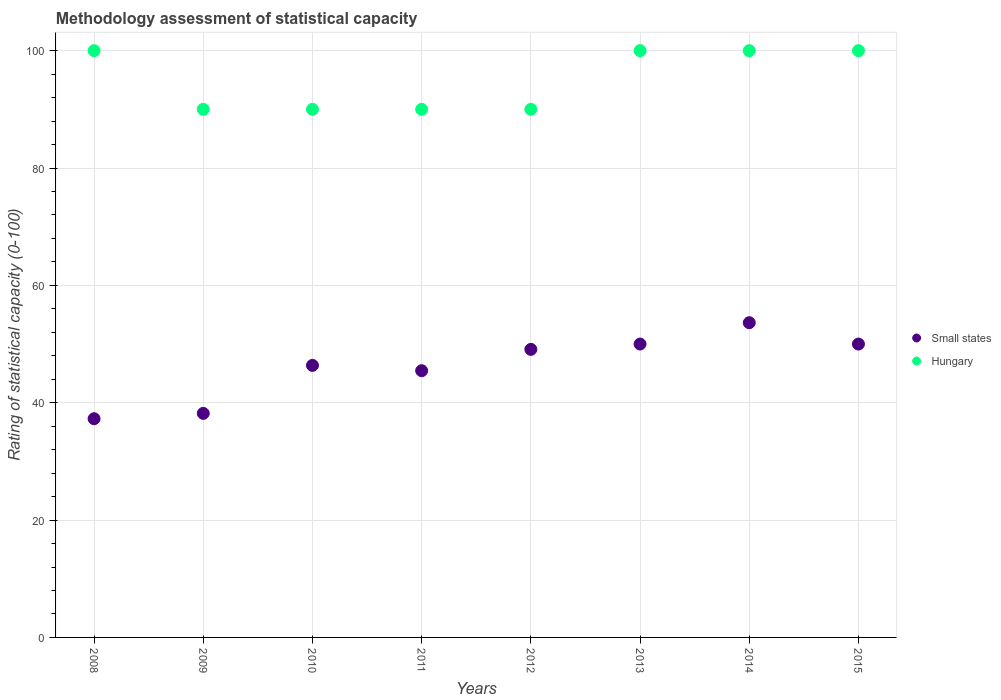Is the number of dotlines equal to the number of legend labels?
Your response must be concise. Yes. What is the rating of statistical capacity in Hungary in 2008?
Make the answer very short. 100. Across all years, what is the maximum rating of statistical capacity in Small states?
Make the answer very short. 53.64. Across all years, what is the minimum rating of statistical capacity in Hungary?
Your response must be concise. 90. In which year was the rating of statistical capacity in Small states maximum?
Your response must be concise. 2014. In which year was the rating of statistical capacity in Small states minimum?
Provide a succinct answer. 2008. What is the total rating of statistical capacity in Hungary in the graph?
Your answer should be compact. 760. What is the difference between the rating of statistical capacity in Small states in 2010 and that in 2011?
Keep it short and to the point. 0.91. What is the difference between the rating of statistical capacity in Small states in 2010 and the rating of statistical capacity in Hungary in 2012?
Give a very brief answer. -43.64. What is the average rating of statistical capacity in Small states per year?
Provide a short and direct response. 46.25. In the year 2008, what is the difference between the rating of statistical capacity in Hungary and rating of statistical capacity in Small states?
Provide a succinct answer. 62.73. Is the difference between the rating of statistical capacity in Hungary in 2008 and 2009 greater than the difference between the rating of statistical capacity in Small states in 2008 and 2009?
Keep it short and to the point. Yes. What is the difference between the highest and the second highest rating of statistical capacity in Hungary?
Keep it short and to the point. 0. What is the difference between the highest and the lowest rating of statistical capacity in Small states?
Provide a short and direct response. 16.36. In how many years, is the rating of statistical capacity in Hungary greater than the average rating of statistical capacity in Hungary taken over all years?
Your answer should be compact. 4. Is the sum of the rating of statistical capacity in Small states in 2008 and 2014 greater than the maximum rating of statistical capacity in Hungary across all years?
Give a very brief answer. No. Does the rating of statistical capacity in Hungary monotonically increase over the years?
Offer a terse response. No. Is the rating of statistical capacity in Hungary strictly less than the rating of statistical capacity in Small states over the years?
Provide a succinct answer. No. How many dotlines are there?
Ensure brevity in your answer.  2. How many years are there in the graph?
Offer a very short reply. 8. What is the difference between two consecutive major ticks on the Y-axis?
Offer a terse response. 20. Are the values on the major ticks of Y-axis written in scientific E-notation?
Your answer should be very brief. No. Does the graph contain grids?
Offer a terse response. Yes. Where does the legend appear in the graph?
Your answer should be compact. Center right. How many legend labels are there?
Ensure brevity in your answer.  2. How are the legend labels stacked?
Offer a terse response. Vertical. What is the title of the graph?
Your answer should be very brief. Methodology assessment of statistical capacity. Does "Bahrain" appear as one of the legend labels in the graph?
Provide a short and direct response. No. What is the label or title of the Y-axis?
Your answer should be very brief. Rating of statistical capacity (0-100). What is the Rating of statistical capacity (0-100) of Small states in 2008?
Your answer should be compact. 37.27. What is the Rating of statistical capacity (0-100) of Small states in 2009?
Ensure brevity in your answer.  38.18. What is the Rating of statistical capacity (0-100) of Hungary in 2009?
Your answer should be compact. 90. What is the Rating of statistical capacity (0-100) of Small states in 2010?
Your answer should be compact. 46.36. What is the Rating of statistical capacity (0-100) of Hungary in 2010?
Make the answer very short. 90. What is the Rating of statistical capacity (0-100) of Small states in 2011?
Offer a terse response. 45.45. What is the Rating of statistical capacity (0-100) of Hungary in 2011?
Your response must be concise. 90. What is the Rating of statistical capacity (0-100) in Small states in 2012?
Ensure brevity in your answer.  49.09. What is the Rating of statistical capacity (0-100) of Hungary in 2013?
Ensure brevity in your answer.  100. What is the Rating of statistical capacity (0-100) of Small states in 2014?
Keep it short and to the point. 53.64. What is the Rating of statistical capacity (0-100) in Hungary in 2015?
Your response must be concise. 100. Across all years, what is the maximum Rating of statistical capacity (0-100) of Small states?
Provide a succinct answer. 53.64. Across all years, what is the minimum Rating of statistical capacity (0-100) in Small states?
Your response must be concise. 37.27. Across all years, what is the minimum Rating of statistical capacity (0-100) of Hungary?
Your response must be concise. 90. What is the total Rating of statistical capacity (0-100) in Small states in the graph?
Your response must be concise. 370. What is the total Rating of statistical capacity (0-100) in Hungary in the graph?
Provide a short and direct response. 760. What is the difference between the Rating of statistical capacity (0-100) in Small states in 2008 and that in 2009?
Ensure brevity in your answer.  -0.91. What is the difference between the Rating of statistical capacity (0-100) in Hungary in 2008 and that in 2009?
Provide a succinct answer. 10. What is the difference between the Rating of statistical capacity (0-100) of Small states in 2008 and that in 2010?
Your answer should be compact. -9.09. What is the difference between the Rating of statistical capacity (0-100) of Hungary in 2008 and that in 2010?
Provide a succinct answer. 10. What is the difference between the Rating of statistical capacity (0-100) of Small states in 2008 and that in 2011?
Your answer should be very brief. -8.18. What is the difference between the Rating of statistical capacity (0-100) in Small states in 2008 and that in 2012?
Keep it short and to the point. -11.82. What is the difference between the Rating of statistical capacity (0-100) of Small states in 2008 and that in 2013?
Provide a succinct answer. -12.73. What is the difference between the Rating of statistical capacity (0-100) of Small states in 2008 and that in 2014?
Your answer should be very brief. -16.36. What is the difference between the Rating of statistical capacity (0-100) of Hungary in 2008 and that in 2014?
Your answer should be very brief. 0. What is the difference between the Rating of statistical capacity (0-100) of Small states in 2008 and that in 2015?
Give a very brief answer. -12.73. What is the difference between the Rating of statistical capacity (0-100) of Hungary in 2008 and that in 2015?
Ensure brevity in your answer.  0. What is the difference between the Rating of statistical capacity (0-100) of Small states in 2009 and that in 2010?
Give a very brief answer. -8.18. What is the difference between the Rating of statistical capacity (0-100) of Small states in 2009 and that in 2011?
Keep it short and to the point. -7.27. What is the difference between the Rating of statistical capacity (0-100) in Hungary in 2009 and that in 2011?
Offer a terse response. 0. What is the difference between the Rating of statistical capacity (0-100) in Small states in 2009 and that in 2012?
Provide a short and direct response. -10.91. What is the difference between the Rating of statistical capacity (0-100) of Hungary in 2009 and that in 2012?
Keep it short and to the point. 0. What is the difference between the Rating of statistical capacity (0-100) in Small states in 2009 and that in 2013?
Keep it short and to the point. -11.82. What is the difference between the Rating of statistical capacity (0-100) in Small states in 2009 and that in 2014?
Ensure brevity in your answer.  -15.45. What is the difference between the Rating of statistical capacity (0-100) of Small states in 2009 and that in 2015?
Make the answer very short. -11.82. What is the difference between the Rating of statistical capacity (0-100) of Hungary in 2009 and that in 2015?
Keep it short and to the point. -10. What is the difference between the Rating of statistical capacity (0-100) in Small states in 2010 and that in 2012?
Give a very brief answer. -2.73. What is the difference between the Rating of statistical capacity (0-100) in Small states in 2010 and that in 2013?
Make the answer very short. -3.64. What is the difference between the Rating of statistical capacity (0-100) in Small states in 2010 and that in 2014?
Offer a terse response. -7.27. What is the difference between the Rating of statistical capacity (0-100) of Small states in 2010 and that in 2015?
Keep it short and to the point. -3.64. What is the difference between the Rating of statistical capacity (0-100) in Small states in 2011 and that in 2012?
Give a very brief answer. -3.64. What is the difference between the Rating of statistical capacity (0-100) in Hungary in 2011 and that in 2012?
Your answer should be very brief. 0. What is the difference between the Rating of statistical capacity (0-100) of Small states in 2011 and that in 2013?
Your response must be concise. -4.55. What is the difference between the Rating of statistical capacity (0-100) of Hungary in 2011 and that in 2013?
Provide a succinct answer. -10. What is the difference between the Rating of statistical capacity (0-100) of Small states in 2011 and that in 2014?
Ensure brevity in your answer.  -8.18. What is the difference between the Rating of statistical capacity (0-100) of Hungary in 2011 and that in 2014?
Keep it short and to the point. -10. What is the difference between the Rating of statistical capacity (0-100) in Small states in 2011 and that in 2015?
Offer a terse response. -4.55. What is the difference between the Rating of statistical capacity (0-100) of Small states in 2012 and that in 2013?
Your answer should be very brief. -0.91. What is the difference between the Rating of statistical capacity (0-100) in Small states in 2012 and that in 2014?
Your response must be concise. -4.55. What is the difference between the Rating of statistical capacity (0-100) of Small states in 2012 and that in 2015?
Make the answer very short. -0.91. What is the difference between the Rating of statistical capacity (0-100) in Hungary in 2012 and that in 2015?
Provide a succinct answer. -10. What is the difference between the Rating of statistical capacity (0-100) in Small states in 2013 and that in 2014?
Your answer should be very brief. -3.64. What is the difference between the Rating of statistical capacity (0-100) in Hungary in 2013 and that in 2014?
Ensure brevity in your answer.  0. What is the difference between the Rating of statistical capacity (0-100) of Small states in 2014 and that in 2015?
Your answer should be compact. 3.64. What is the difference between the Rating of statistical capacity (0-100) of Hungary in 2014 and that in 2015?
Provide a short and direct response. 0. What is the difference between the Rating of statistical capacity (0-100) in Small states in 2008 and the Rating of statistical capacity (0-100) in Hungary in 2009?
Your response must be concise. -52.73. What is the difference between the Rating of statistical capacity (0-100) in Small states in 2008 and the Rating of statistical capacity (0-100) in Hungary in 2010?
Make the answer very short. -52.73. What is the difference between the Rating of statistical capacity (0-100) of Small states in 2008 and the Rating of statistical capacity (0-100) of Hungary in 2011?
Your answer should be very brief. -52.73. What is the difference between the Rating of statistical capacity (0-100) of Small states in 2008 and the Rating of statistical capacity (0-100) of Hungary in 2012?
Provide a succinct answer. -52.73. What is the difference between the Rating of statistical capacity (0-100) of Small states in 2008 and the Rating of statistical capacity (0-100) of Hungary in 2013?
Give a very brief answer. -62.73. What is the difference between the Rating of statistical capacity (0-100) in Small states in 2008 and the Rating of statistical capacity (0-100) in Hungary in 2014?
Give a very brief answer. -62.73. What is the difference between the Rating of statistical capacity (0-100) in Small states in 2008 and the Rating of statistical capacity (0-100) in Hungary in 2015?
Provide a succinct answer. -62.73. What is the difference between the Rating of statistical capacity (0-100) of Small states in 2009 and the Rating of statistical capacity (0-100) of Hungary in 2010?
Make the answer very short. -51.82. What is the difference between the Rating of statistical capacity (0-100) of Small states in 2009 and the Rating of statistical capacity (0-100) of Hungary in 2011?
Make the answer very short. -51.82. What is the difference between the Rating of statistical capacity (0-100) of Small states in 2009 and the Rating of statistical capacity (0-100) of Hungary in 2012?
Your answer should be very brief. -51.82. What is the difference between the Rating of statistical capacity (0-100) in Small states in 2009 and the Rating of statistical capacity (0-100) in Hungary in 2013?
Keep it short and to the point. -61.82. What is the difference between the Rating of statistical capacity (0-100) in Small states in 2009 and the Rating of statistical capacity (0-100) in Hungary in 2014?
Make the answer very short. -61.82. What is the difference between the Rating of statistical capacity (0-100) in Small states in 2009 and the Rating of statistical capacity (0-100) in Hungary in 2015?
Provide a succinct answer. -61.82. What is the difference between the Rating of statistical capacity (0-100) of Small states in 2010 and the Rating of statistical capacity (0-100) of Hungary in 2011?
Ensure brevity in your answer.  -43.64. What is the difference between the Rating of statistical capacity (0-100) of Small states in 2010 and the Rating of statistical capacity (0-100) of Hungary in 2012?
Give a very brief answer. -43.64. What is the difference between the Rating of statistical capacity (0-100) of Small states in 2010 and the Rating of statistical capacity (0-100) of Hungary in 2013?
Provide a short and direct response. -53.64. What is the difference between the Rating of statistical capacity (0-100) of Small states in 2010 and the Rating of statistical capacity (0-100) of Hungary in 2014?
Provide a succinct answer. -53.64. What is the difference between the Rating of statistical capacity (0-100) of Small states in 2010 and the Rating of statistical capacity (0-100) of Hungary in 2015?
Your answer should be very brief. -53.64. What is the difference between the Rating of statistical capacity (0-100) of Small states in 2011 and the Rating of statistical capacity (0-100) of Hungary in 2012?
Your answer should be compact. -44.55. What is the difference between the Rating of statistical capacity (0-100) of Small states in 2011 and the Rating of statistical capacity (0-100) of Hungary in 2013?
Give a very brief answer. -54.55. What is the difference between the Rating of statistical capacity (0-100) of Small states in 2011 and the Rating of statistical capacity (0-100) of Hungary in 2014?
Offer a terse response. -54.55. What is the difference between the Rating of statistical capacity (0-100) of Small states in 2011 and the Rating of statistical capacity (0-100) of Hungary in 2015?
Provide a short and direct response. -54.55. What is the difference between the Rating of statistical capacity (0-100) in Small states in 2012 and the Rating of statistical capacity (0-100) in Hungary in 2013?
Give a very brief answer. -50.91. What is the difference between the Rating of statistical capacity (0-100) in Small states in 2012 and the Rating of statistical capacity (0-100) in Hungary in 2014?
Make the answer very short. -50.91. What is the difference between the Rating of statistical capacity (0-100) in Small states in 2012 and the Rating of statistical capacity (0-100) in Hungary in 2015?
Your answer should be very brief. -50.91. What is the difference between the Rating of statistical capacity (0-100) in Small states in 2013 and the Rating of statistical capacity (0-100) in Hungary in 2014?
Your answer should be compact. -50. What is the difference between the Rating of statistical capacity (0-100) in Small states in 2014 and the Rating of statistical capacity (0-100) in Hungary in 2015?
Keep it short and to the point. -46.36. What is the average Rating of statistical capacity (0-100) of Small states per year?
Your answer should be compact. 46.25. What is the average Rating of statistical capacity (0-100) in Hungary per year?
Offer a very short reply. 95. In the year 2008, what is the difference between the Rating of statistical capacity (0-100) in Small states and Rating of statistical capacity (0-100) in Hungary?
Your response must be concise. -62.73. In the year 2009, what is the difference between the Rating of statistical capacity (0-100) in Small states and Rating of statistical capacity (0-100) in Hungary?
Your response must be concise. -51.82. In the year 2010, what is the difference between the Rating of statistical capacity (0-100) of Small states and Rating of statistical capacity (0-100) of Hungary?
Provide a short and direct response. -43.64. In the year 2011, what is the difference between the Rating of statistical capacity (0-100) of Small states and Rating of statistical capacity (0-100) of Hungary?
Provide a short and direct response. -44.55. In the year 2012, what is the difference between the Rating of statistical capacity (0-100) in Small states and Rating of statistical capacity (0-100) in Hungary?
Offer a terse response. -40.91. In the year 2013, what is the difference between the Rating of statistical capacity (0-100) of Small states and Rating of statistical capacity (0-100) of Hungary?
Your response must be concise. -50. In the year 2014, what is the difference between the Rating of statistical capacity (0-100) of Small states and Rating of statistical capacity (0-100) of Hungary?
Offer a very short reply. -46.36. In the year 2015, what is the difference between the Rating of statistical capacity (0-100) in Small states and Rating of statistical capacity (0-100) in Hungary?
Your answer should be compact. -50. What is the ratio of the Rating of statistical capacity (0-100) of Small states in 2008 to that in 2009?
Offer a terse response. 0.98. What is the ratio of the Rating of statistical capacity (0-100) of Small states in 2008 to that in 2010?
Offer a very short reply. 0.8. What is the ratio of the Rating of statistical capacity (0-100) in Small states in 2008 to that in 2011?
Provide a succinct answer. 0.82. What is the ratio of the Rating of statistical capacity (0-100) in Small states in 2008 to that in 2012?
Your response must be concise. 0.76. What is the ratio of the Rating of statistical capacity (0-100) in Hungary in 2008 to that in 2012?
Offer a very short reply. 1.11. What is the ratio of the Rating of statistical capacity (0-100) in Small states in 2008 to that in 2013?
Keep it short and to the point. 0.75. What is the ratio of the Rating of statistical capacity (0-100) in Small states in 2008 to that in 2014?
Ensure brevity in your answer.  0.69. What is the ratio of the Rating of statistical capacity (0-100) of Hungary in 2008 to that in 2014?
Your answer should be compact. 1. What is the ratio of the Rating of statistical capacity (0-100) in Small states in 2008 to that in 2015?
Keep it short and to the point. 0.75. What is the ratio of the Rating of statistical capacity (0-100) of Hungary in 2008 to that in 2015?
Ensure brevity in your answer.  1. What is the ratio of the Rating of statistical capacity (0-100) of Small states in 2009 to that in 2010?
Make the answer very short. 0.82. What is the ratio of the Rating of statistical capacity (0-100) of Hungary in 2009 to that in 2010?
Your answer should be very brief. 1. What is the ratio of the Rating of statistical capacity (0-100) of Small states in 2009 to that in 2011?
Give a very brief answer. 0.84. What is the ratio of the Rating of statistical capacity (0-100) in Hungary in 2009 to that in 2011?
Keep it short and to the point. 1. What is the ratio of the Rating of statistical capacity (0-100) of Small states in 2009 to that in 2012?
Provide a short and direct response. 0.78. What is the ratio of the Rating of statistical capacity (0-100) of Small states in 2009 to that in 2013?
Your response must be concise. 0.76. What is the ratio of the Rating of statistical capacity (0-100) of Hungary in 2009 to that in 2013?
Keep it short and to the point. 0.9. What is the ratio of the Rating of statistical capacity (0-100) in Small states in 2009 to that in 2014?
Provide a succinct answer. 0.71. What is the ratio of the Rating of statistical capacity (0-100) in Hungary in 2009 to that in 2014?
Offer a terse response. 0.9. What is the ratio of the Rating of statistical capacity (0-100) in Small states in 2009 to that in 2015?
Provide a short and direct response. 0.76. What is the ratio of the Rating of statistical capacity (0-100) of Hungary in 2009 to that in 2015?
Provide a short and direct response. 0.9. What is the ratio of the Rating of statistical capacity (0-100) in Small states in 2010 to that in 2011?
Your answer should be compact. 1.02. What is the ratio of the Rating of statistical capacity (0-100) of Hungary in 2010 to that in 2011?
Ensure brevity in your answer.  1. What is the ratio of the Rating of statistical capacity (0-100) in Small states in 2010 to that in 2012?
Your answer should be very brief. 0.94. What is the ratio of the Rating of statistical capacity (0-100) of Hungary in 2010 to that in 2012?
Your response must be concise. 1. What is the ratio of the Rating of statistical capacity (0-100) in Small states in 2010 to that in 2013?
Make the answer very short. 0.93. What is the ratio of the Rating of statistical capacity (0-100) in Small states in 2010 to that in 2014?
Offer a terse response. 0.86. What is the ratio of the Rating of statistical capacity (0-100) in Hungary in 2010 to that in 2014?
Your answer should be compact. 0.9. What is the ratio of the Rating of statistical capacity (0-100) in Small states in 2010 to that in 2015?
Your response must be concise. 0.93. What is the ratio of the Rating of statistical capacity (0-100) in Hungary in 2010 to that in 2015?
Offer a terse response. 0.9. What is the ratio of the Rating of statistical capacity (0-100) of Small states in 2011 to that in 2012?
Provide a succinct answer. 0.93. What is the ratio of the Rating of statistical capacity (0-100) in Small states in 2011 to that in 2013?
Give a very brief answer. 0.91. What is the ratio of the Rating of statistical capacity (0-100) of Hungary in 2011 to that in 2013?
Offer a terse response. 0.9. What is the ratio of the Rating of statistical capacity (0-100) in Small states in 2011 to that in 2014?
Ensure brevity in your answer.  0.85. What is the ratio of the Rating of statistical capacity (0-100) in Hungary in 2011 to that in 2015?
Keep it short and to the point. 0.9. What is the ratio of the Rating of statistical capacity (0-100) of Small states in 2012 to that in 2013?
Offer a very short reply. 0.98. What is the ratio of the Rating of statistical capacity (0-100) of Small states in 2012 to that in 2014?
Give a very brief answer. 0.92. What is the ratio of the Rating of statistical capacity (0-100) of Hungary in 2012 to that in 2014?
Your response must be concise. 0.9. What is the ratio of the Rating of statistical capacity (0-100) in Small states in 2012 to that in 2015?
Make the answer very short. 0.98. What is the ratio of the Rating of statistical capacity (0-100) of Hungary in 2012 to that in 2015?
Give a very brief answer. 0.9. What is the ratio of the Rating of statistical capacity (0-100) in Small states in 2013 to that in 2014?
Your answer should be compact. 0.93. What is the ratio of the Rating of statistical capacity (0-100) of Hungary in 2013 to that in 2014?
Offer a very short reply. 1. What is the ratio of the Rating of statistical capacity (0-100) of Small states in 2013 to that in 2015?
Offer a very short reply. 1. What is the ratio of the Rating of statistical capacity (0-100) of Hungary in 2013 to that in 2015?
Your response must be concise. 1. What is the ratio of the Rating of statistical capacity (0-100) of Small states in 2014 to that in 2015?
Your response must be concise. 1.07. What is the difference between the highest and the second highest Rating of statistical capacity (0-100) in Small states?
Make the answer very short. 3.64. What is the difference between the highest and the lowest Rating of statistical capacity (0-100) in Small states?
Give a very brief answer. 16.36. 